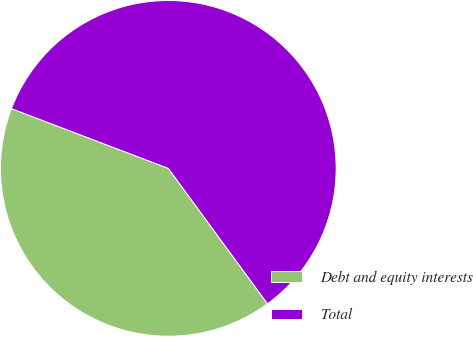Convert chart. <chart><loc_0><loc_0><loc_500><loc_500><pie_chart><fcel>Debt and equity interests<fcel>Total<nl><fcel>40.85%<fcel>59.15%<nl></chart> 